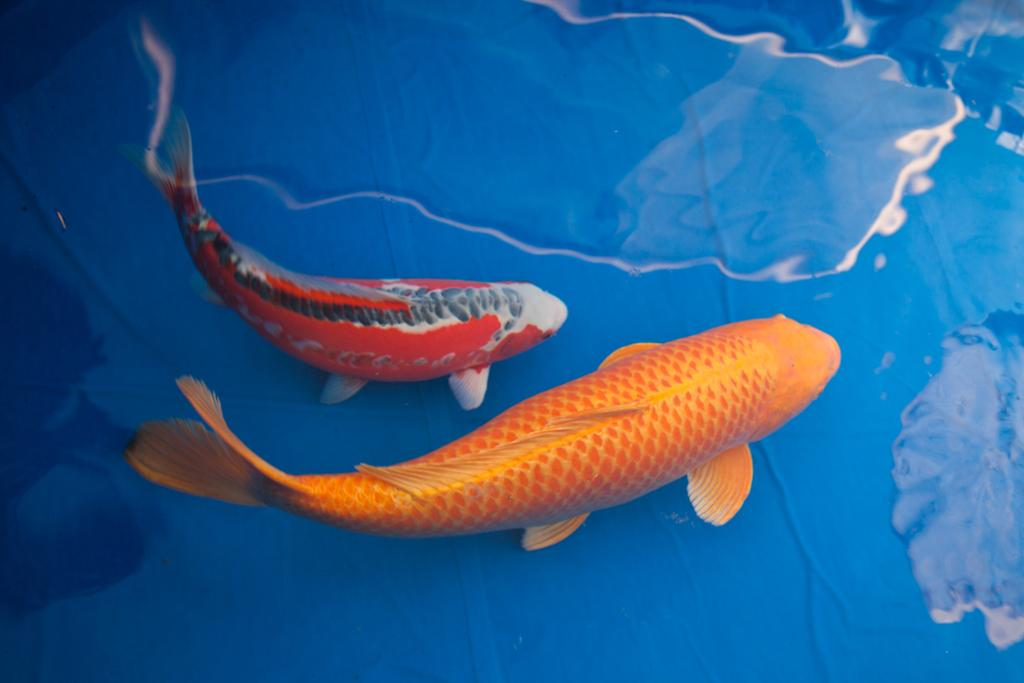What animals are present in the image? There are two fishes in the image. Where are the fishes located? The fishes are in water. What color is the background of the image? The background of the image is blue. What type of mask is the goldfish wearing in the image? There is no goldfish present in the image, and no masks are visible. 